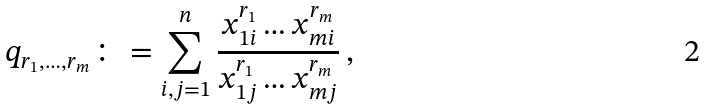<formula> <loc_0><loc_0><loc_500><loc_500>q _ { r _ { 1 } , \dots , r _ { m } } \colon = \sum _ { i , j = 1 } ^ { n } \frac { x _ { 1 i } ^ { r _ { 1 } } \dots x _ { m i } ^ { r _ { m } } } { x _ { 1 j } ^ { r _ { 1 } } \dots x _ { m j } ^ { r _ { m } } } \, ,</formula> 